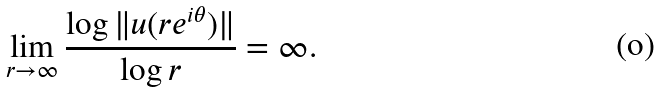<formula> <loc_0><loc_0><loc_500><loc_500>\lim _ { r \to \infty } \frac { \log \| u ( r e ^ { i \theta } ) \| } { \log r } = \infty .</formula> 